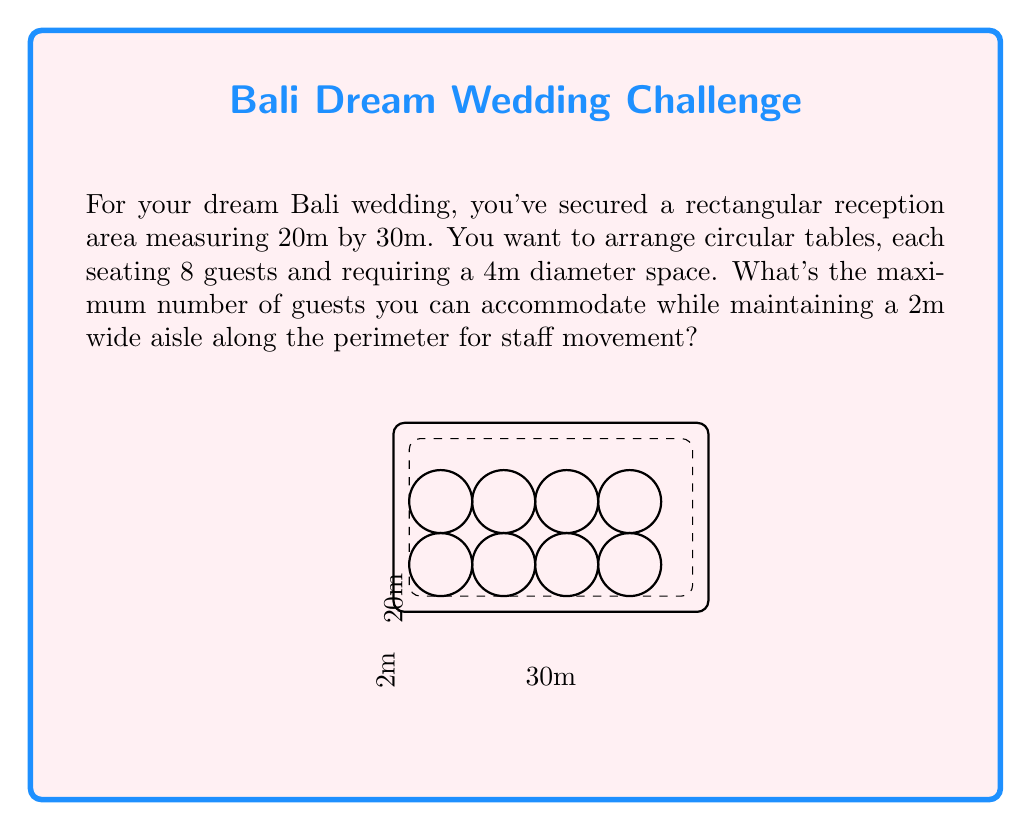What is the answer to this math problem? Let's approach this step-by-step:

1) First, calculate the usable area after accounting for the 2m aisle:
   Usable length = $30m - 2(2m) = 26m$
   Usable width = $20m - 2(2m) = 16m$

2) Each table requires a 4m diameter space. This means we need a 4m x 4m square for each table.

3) Calculate how many tables can fit along each dimension:
   Length: $26 \div 4 = 6.5$ (we can fit 6 tables)
   Width: $16 \div 4 = 4$ (we can fit 4 tables)

4) Total number of tables: $6 \times 4 = 24$

5) Each table seats 8 guests, so the total number of guests:
   $24 \times 8 = 192$

Therefore, the maximum number of guests that can be accommodated is 192.
Answer: 192 guests 